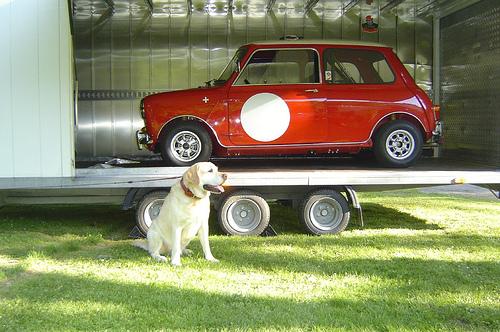What kind of dog is sitting in the grass?
Short answer required. Lab. What color is the car?
Short answer required. Red. What is the shape that is on the car door?
Give a very brief answer. Circle. 